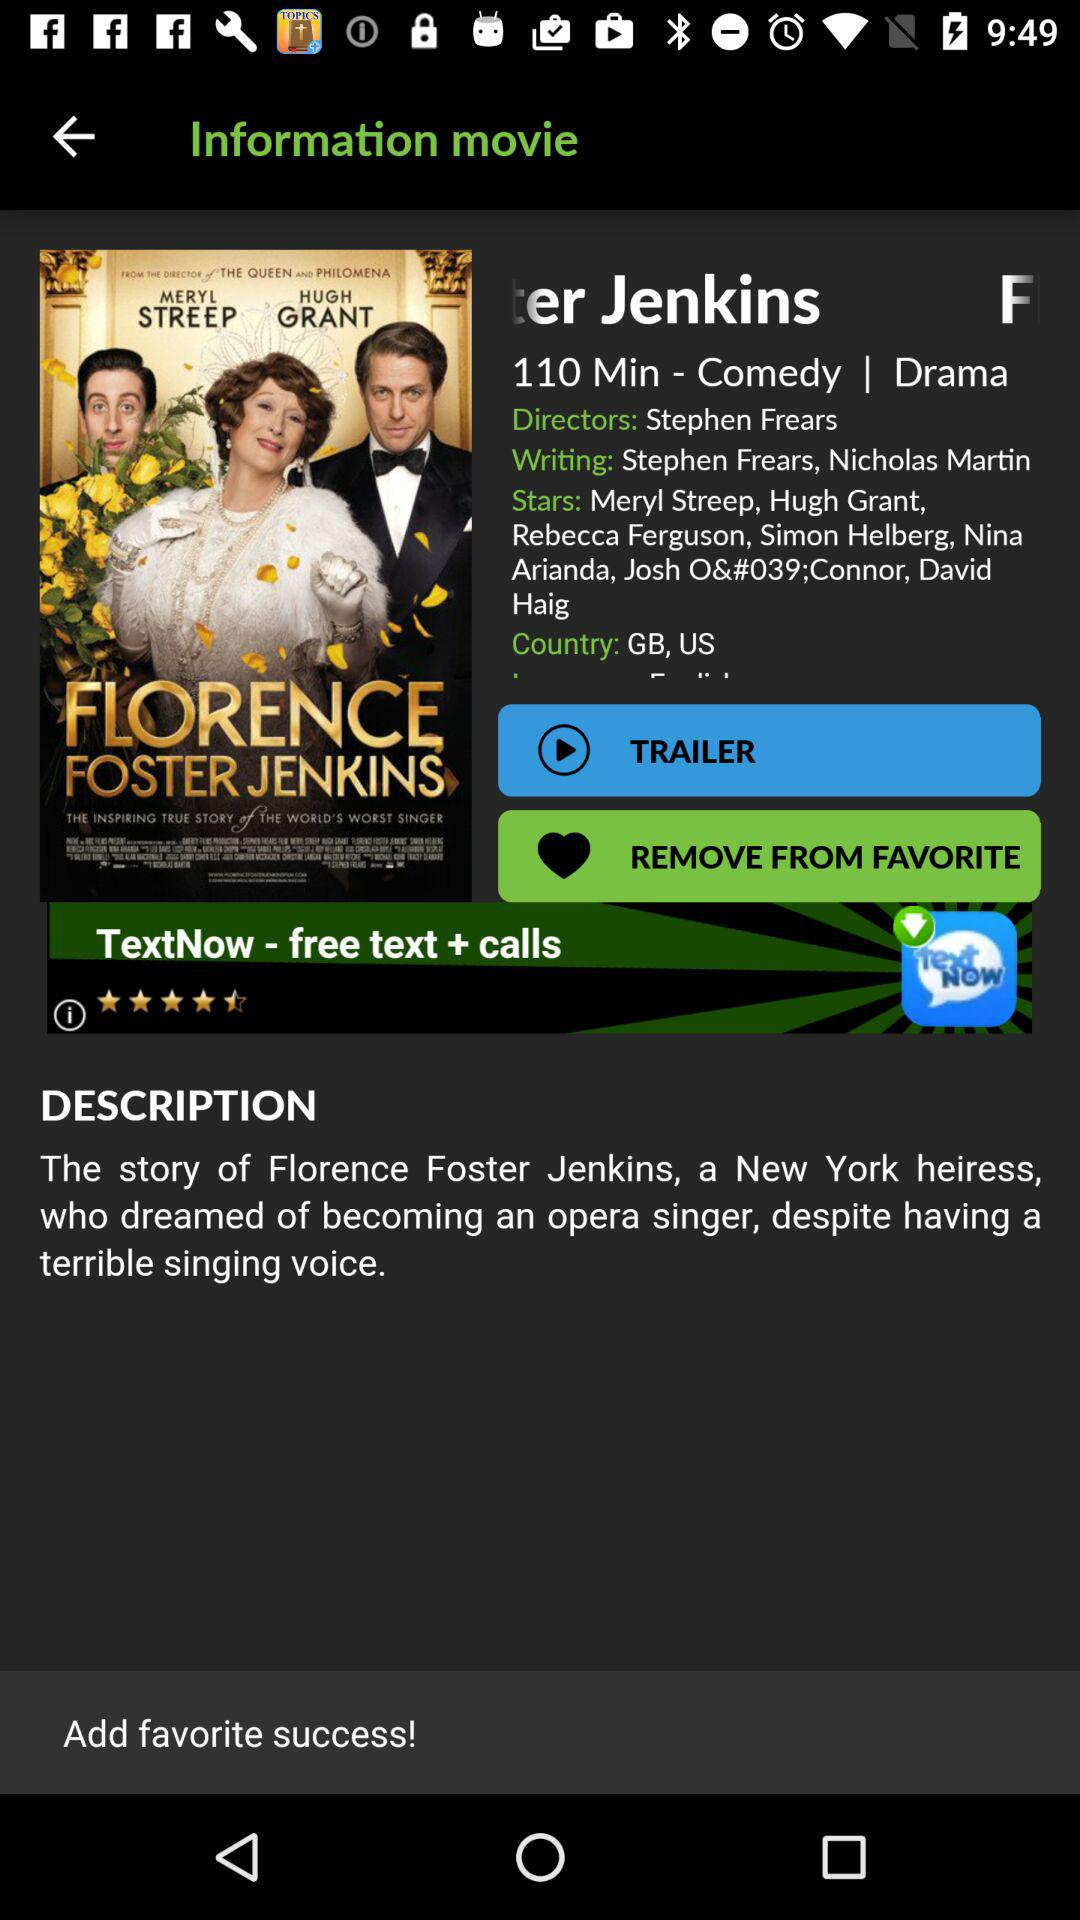Which of the actors performed in the movie? The actors are Meryl Streep, Hugh Grant, Rebecca Ferguson, Simon Helberg, Nina Arianda, Josh O'Connor, and David Haig. 